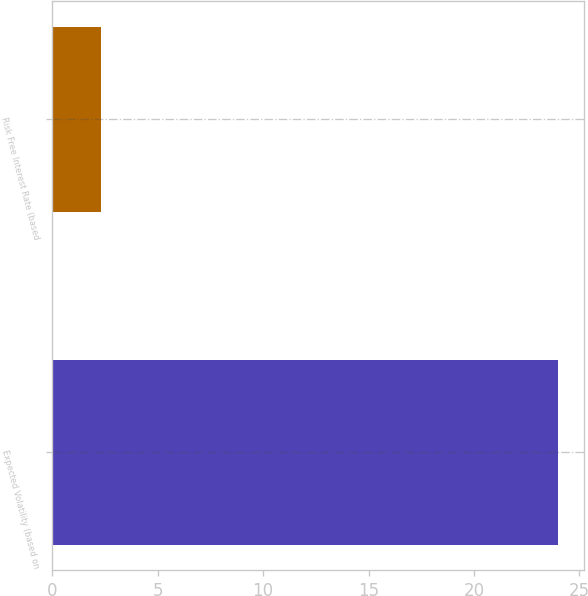Convert chart. <chart><loc_0><loc_0><loc_500><loc_500><bar_chart><fcel>Expected Volatility (based on<fcel>Risk Free Interest Rate (based<nl><fcel>24<fcel>2.32<nl></chart> 